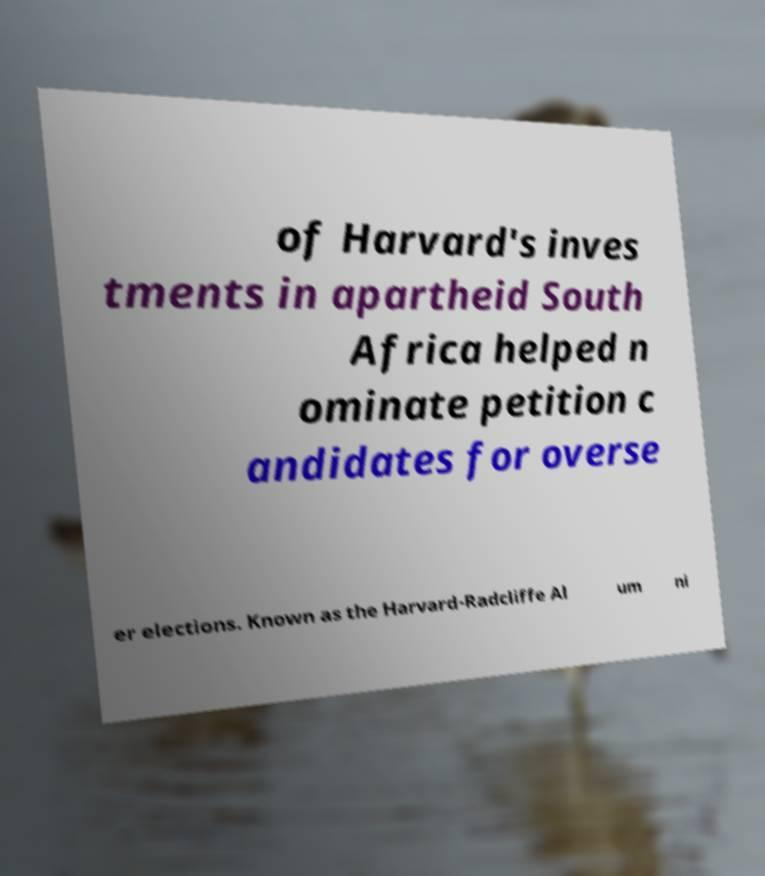Could you assist in decoding the text presented in this image and type it out clearly? of Harvard's inves tments in apartheid South Africa helped n ominate petition c andidates for overse er elections. Known as the Harvard-Radcliffe Al um ni 